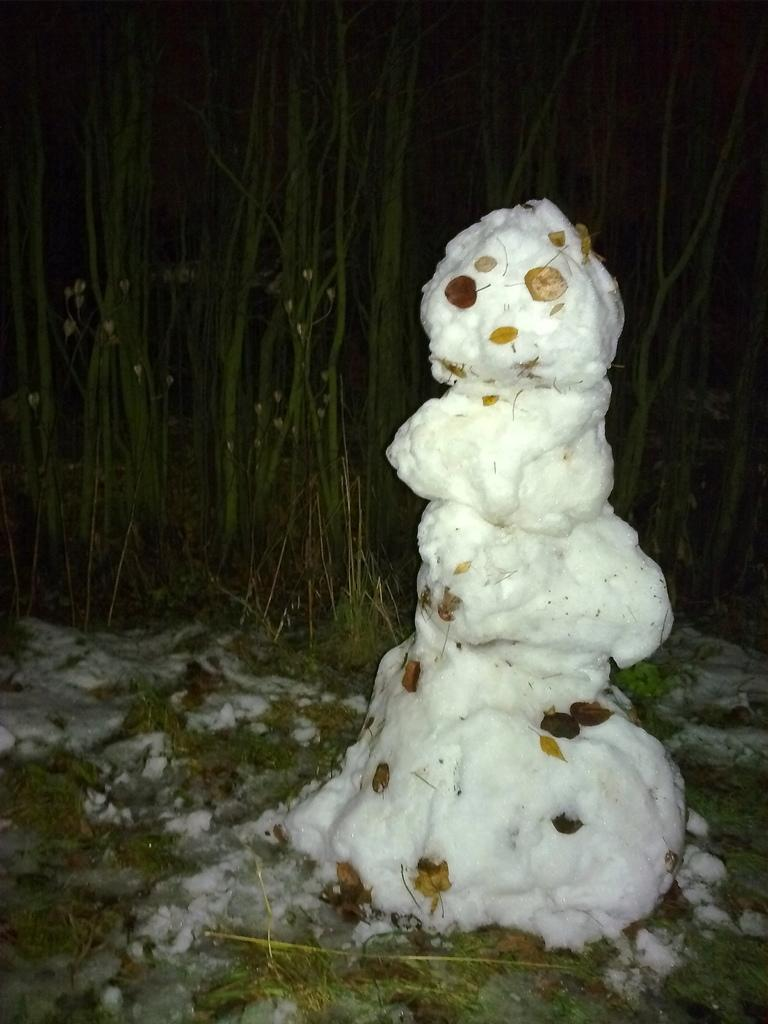What type of structure is made out of cotton in the image? There is a structure made out of cotton in the image, but the specific type cannot be determined from the provided facts. What type of vegetation is visible in the image? There are trees visible in the image. What type of alarm can be heard going off in the image? There is no alarm present in the image, and therefore no such sound can be heard. How many girls are visible in the image? There is no mention of girls in the provided facts, and therefore no such individuals can be observed. 